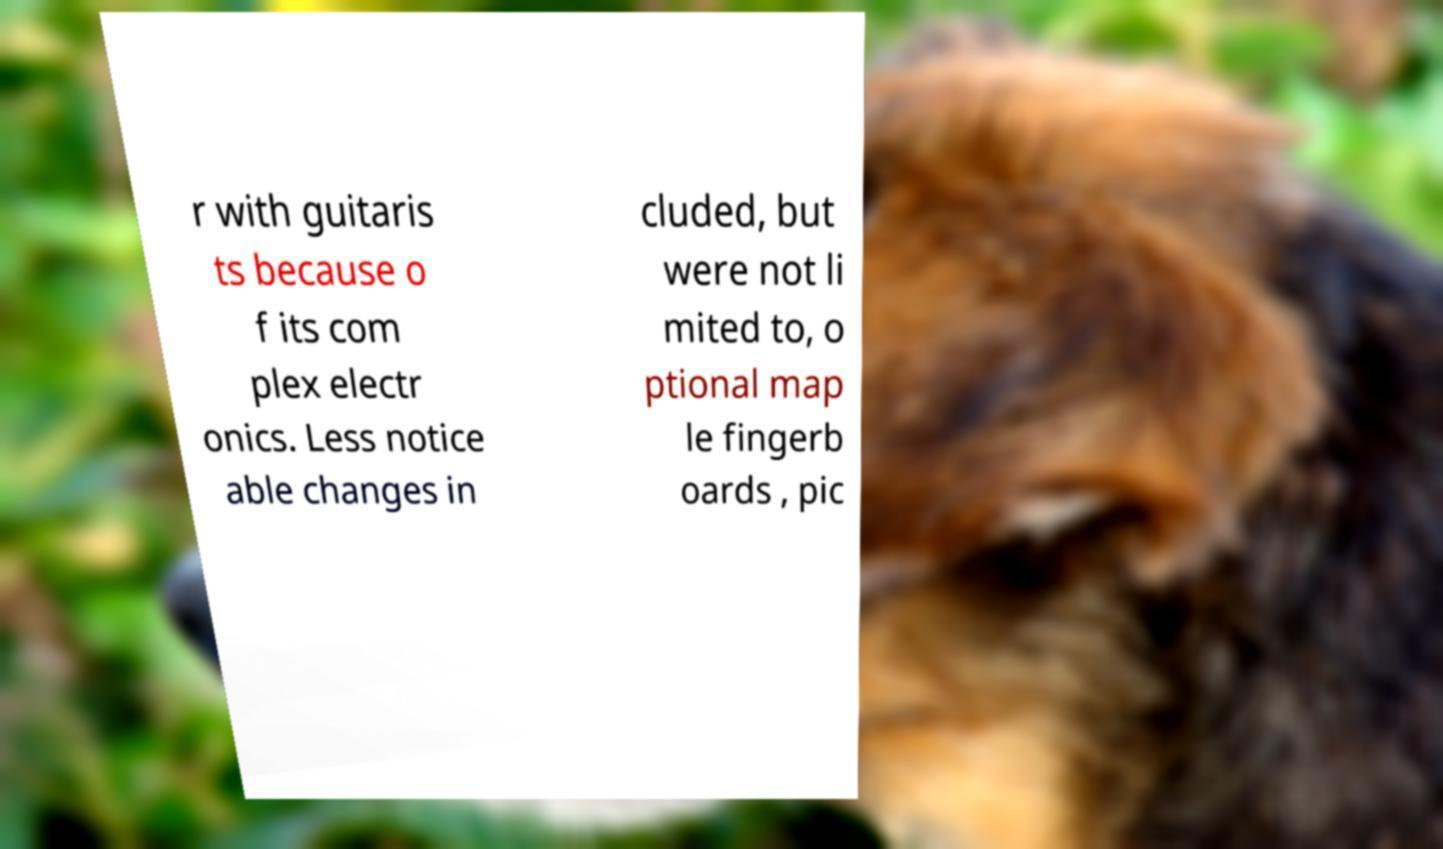Please identify and transcribe the text found in this image. r with guitaris ts because o f its com plex electr onics. Less notice able changes in cluded, but were not li mited to, o ptional map le fingerb oards , pic 